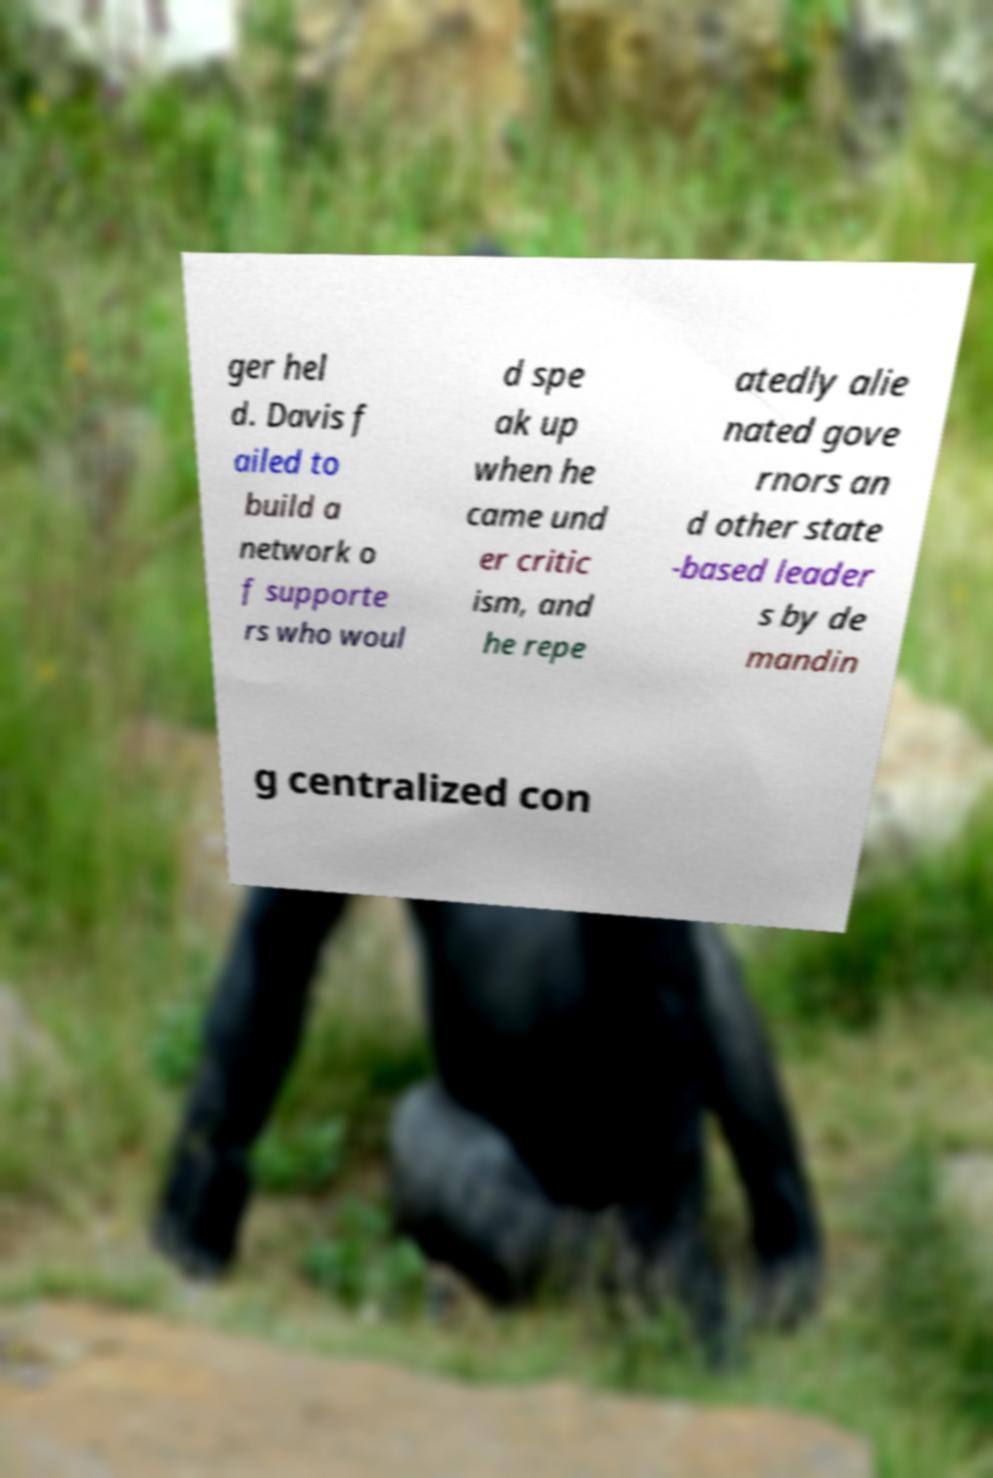Please identify and transcribe the text found in this image. ger hel d. Davis f ailed to build a network o f supporte rs who woul d spe ak up when he came und er critic ism, and he repe atedly alie nated gove rnors an d other state -based leader s by de mandin g centralized con 